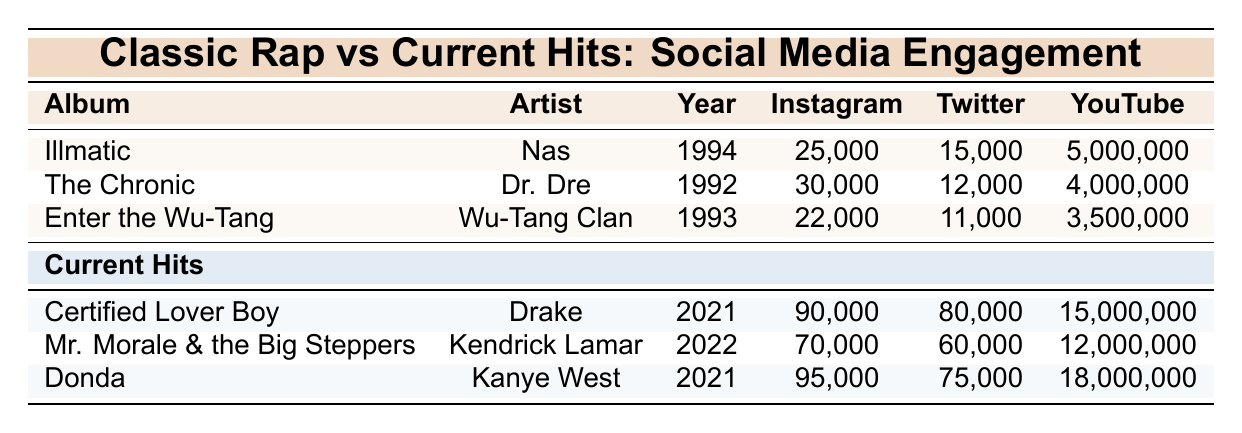What is the Instagram engagement of "Illmatic"? The table indicates that "Illmatic," an album by Nas released in 1994, has an Instagram engagement of 25,000.
Answer: 25,000 Which album has the highest YouTube views among the classic rap albums? According to the table, "Illmatic" by Nas has the highest YouTube views at 5,000,000 compared to the other classic albums listed.
Answer: Illmatic What is the difference in Instagram engagements between "Donda" and "The Chronic"? "Donda" has 95,000 Instagram engagements and "The Chronic" has 30,000. The difference is 95,000 - 30,000 = 65,000.
Answer: 65,000 Is "Mr. Morale & the Big Steppers" by Kendrick Lamar older than "The Chronic"? "The Chronic" was released in 1992, while "Mr. Morale & the Big Steppers" was released in 2022, making "The Chronic" older.
Answer: No What is the average Twitter engagement for the classic rap albums listed? The Twitter engagements for the classic albums are 15,000 (Illmatic), 12,000 (The Chronic), and 11,000 (Enter the Wu-Tang). The sum is 15,000 + 12,000 + 11,000 = 38,000, and with 3 albums, the average is 38,000 / 3 = 12,666.67, which rounds to 12,667.
Answer: 12,667 Which current hit has lower Instagram engagements, "Certified Lover Boy" or "Mr. Morale & the Big Steppers"? "Certified Lover Boy" has 90,000 Instagram engagements and "Mr. Morale & the Big Steppers" has 70,000. Thus, "Mr. Morale & the Big Steppers" has lower engagements.
Answer: Mr. Morale & the Big Steppers How many more average YouTube views do current hits have compared to classic rap albums? Current hits have YouTube views of 15,000,000 (Certified Lover Boy), 12,000,000 (Mr. Morale), and 18,000,000 (Donda), summing to 45,000,000. The average is 45,000,000 / 3 = 15,000,000. Classic albums have 5,000,000 (Illmatic), 4,000,000 (The Chronic), and 3,500,000 (Enter the Wu-Tang), summing to 12,500,000 with an average of 4,166,667. The difference is 15,000,000 - 4,166,667 = 10,833,333.
Answer: 10,833,333 What is the total combined Instagram engagement of all classic rap albums? The Instagram engagements are 25,000 (Illmatic) + 30,000 (The Chronic) + 22,000 (Enter the Wu-Tang), adding up to a total of 25,000 + 30,000 + 22,000 = 77,000.
Answer: 77,000 